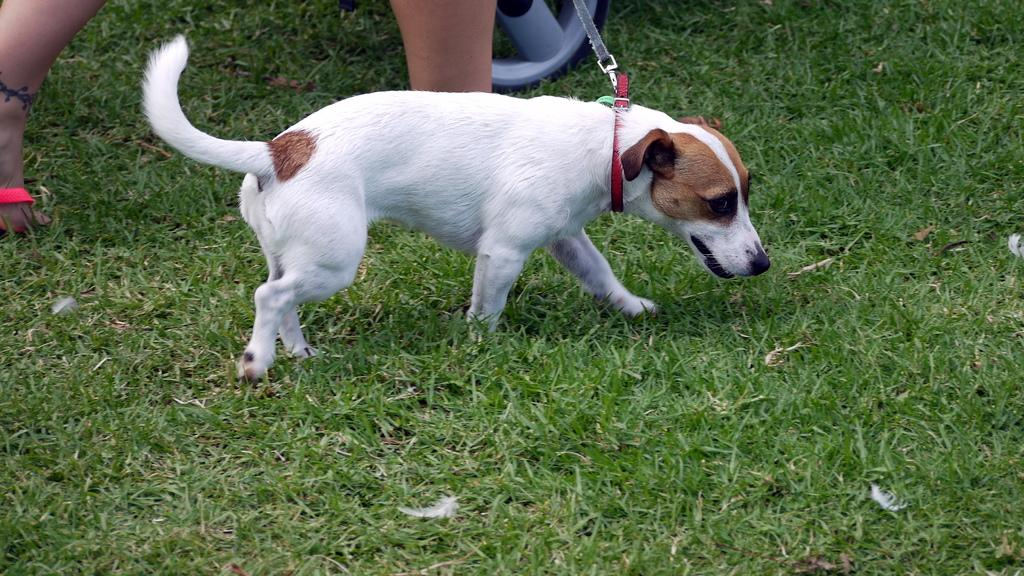What type of animal is in the image? There is a dog in the image. What colors can be seen on the dog's fur? The dog has white, brown, and black colors. Whose legs are visible in the image? There are person's legs visible in the image. What type of terrain is in the image? There is grass in the image. What is the dog wearing? The dog is wearing a belt. What type of caption is written on the duck in the image? There is no duck present in the image, and therefore no caption can be found on it. 